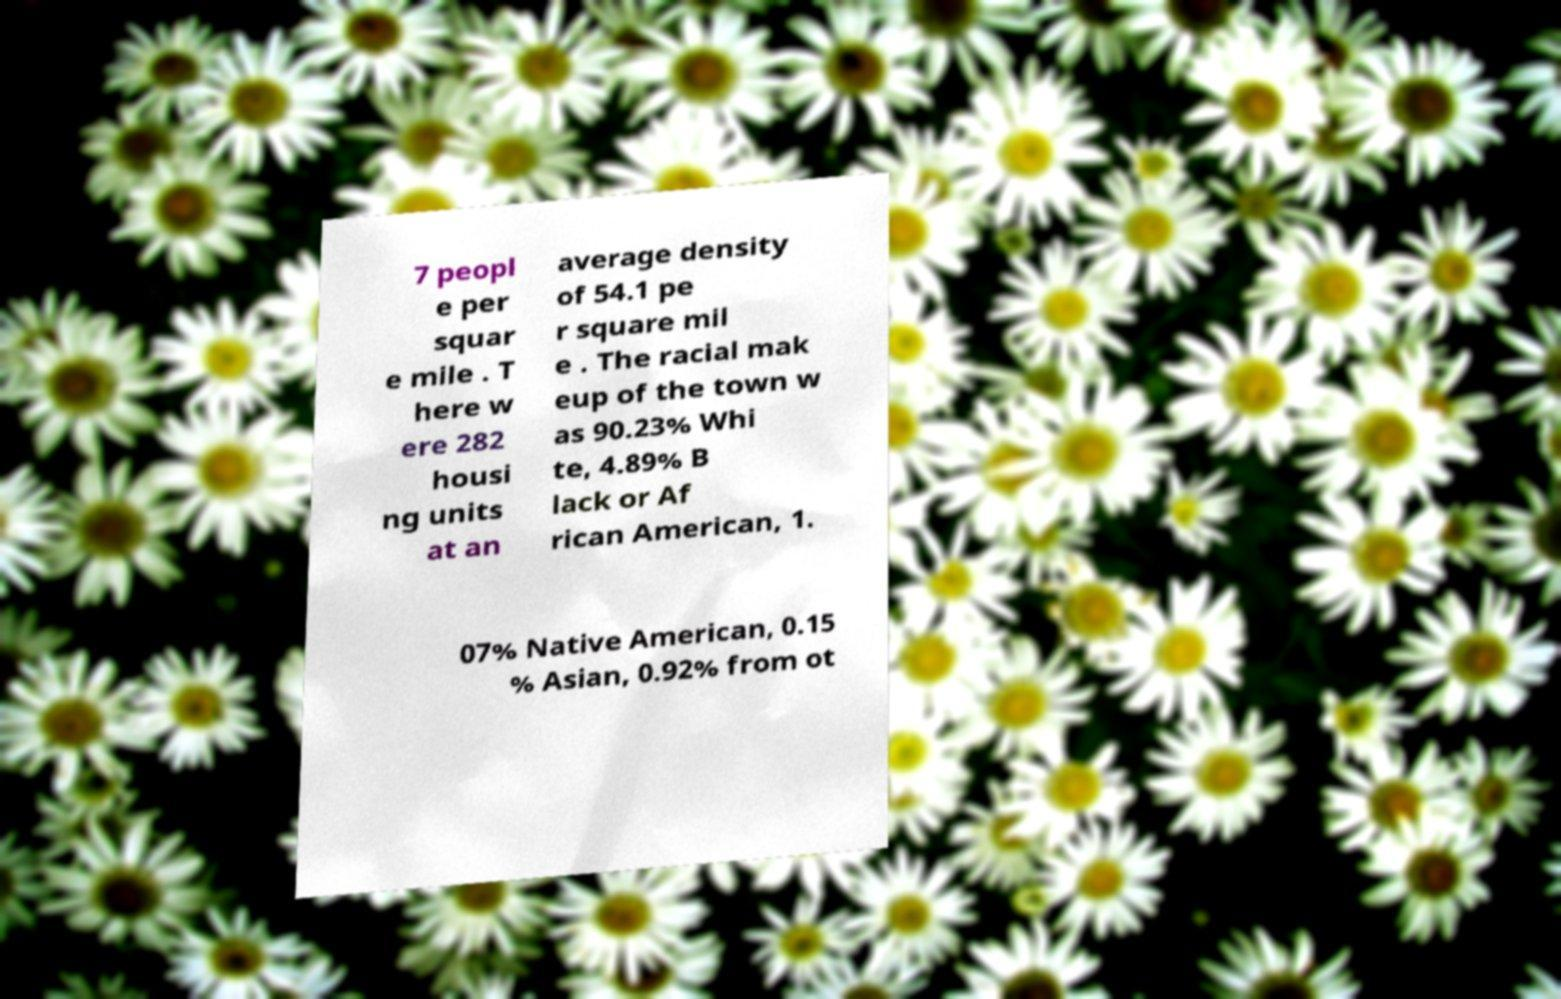What messages or text are displayed in this image? I need them in a readable, typed format. 7 peopl e per squar e mile . T here w ere 282 housi ng units at an average density of 54.1 pe r square mil e . The racial mak eup of the town w as 90.23% Whi te, 4.89% B lack or Af rican American, 1. 07% Native American, 0.15 % Asian, 0.92% from ot 